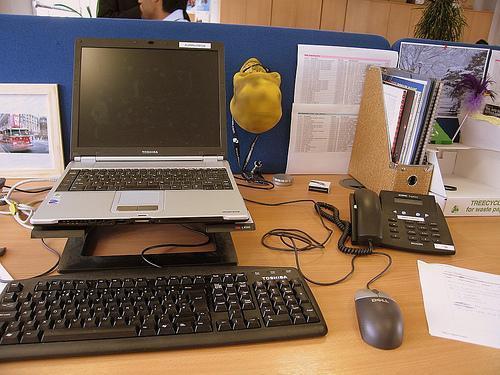How many women?
Give a very brief answer. 0. How many keyboards can you see?
Give a very brief answer. 2. 